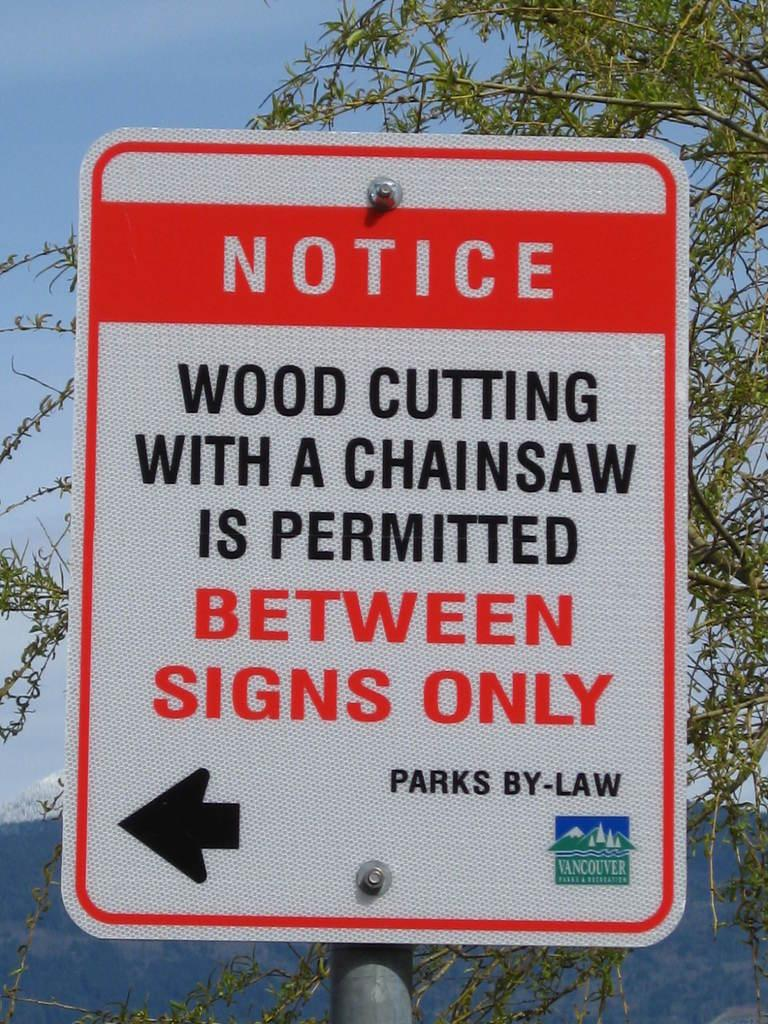<image>
Give a short and clear explanation of the subsequent image. A notice sign outdoors reads notice wood cutting with a chainsaw is permitted between signs only. 